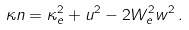Convert formula to latex. <formula><loc_0><loc_0><loc_500><loc_500>\kappa n = \kappa _ { e } ^ { 2 } + u ^ { 2 } - 2 W _ { e } ^ { 2 } w ^ { 2 } \, .</formula> 